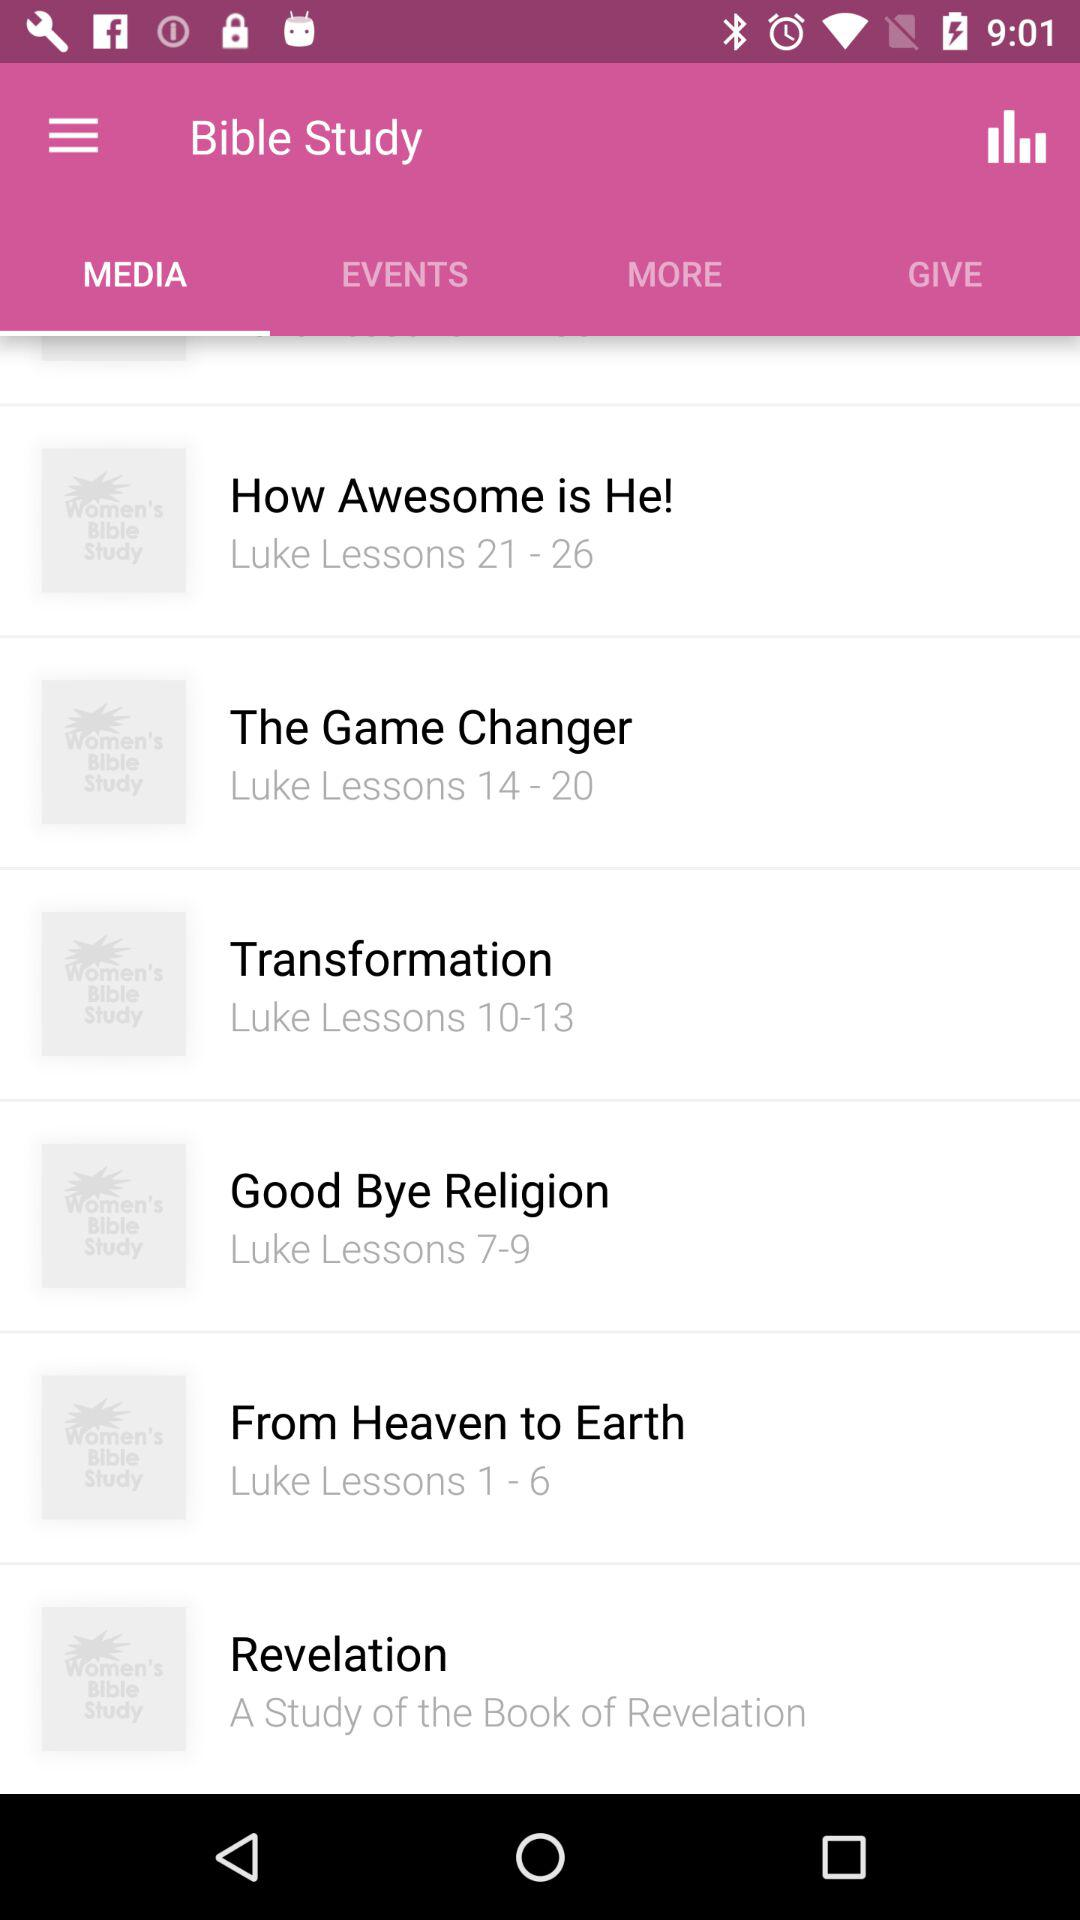Which media consist of "Luke Lessons 21 - 26"? The media that consist of "Luke Lessons 21 - 26" is "How Awesome is He!". 